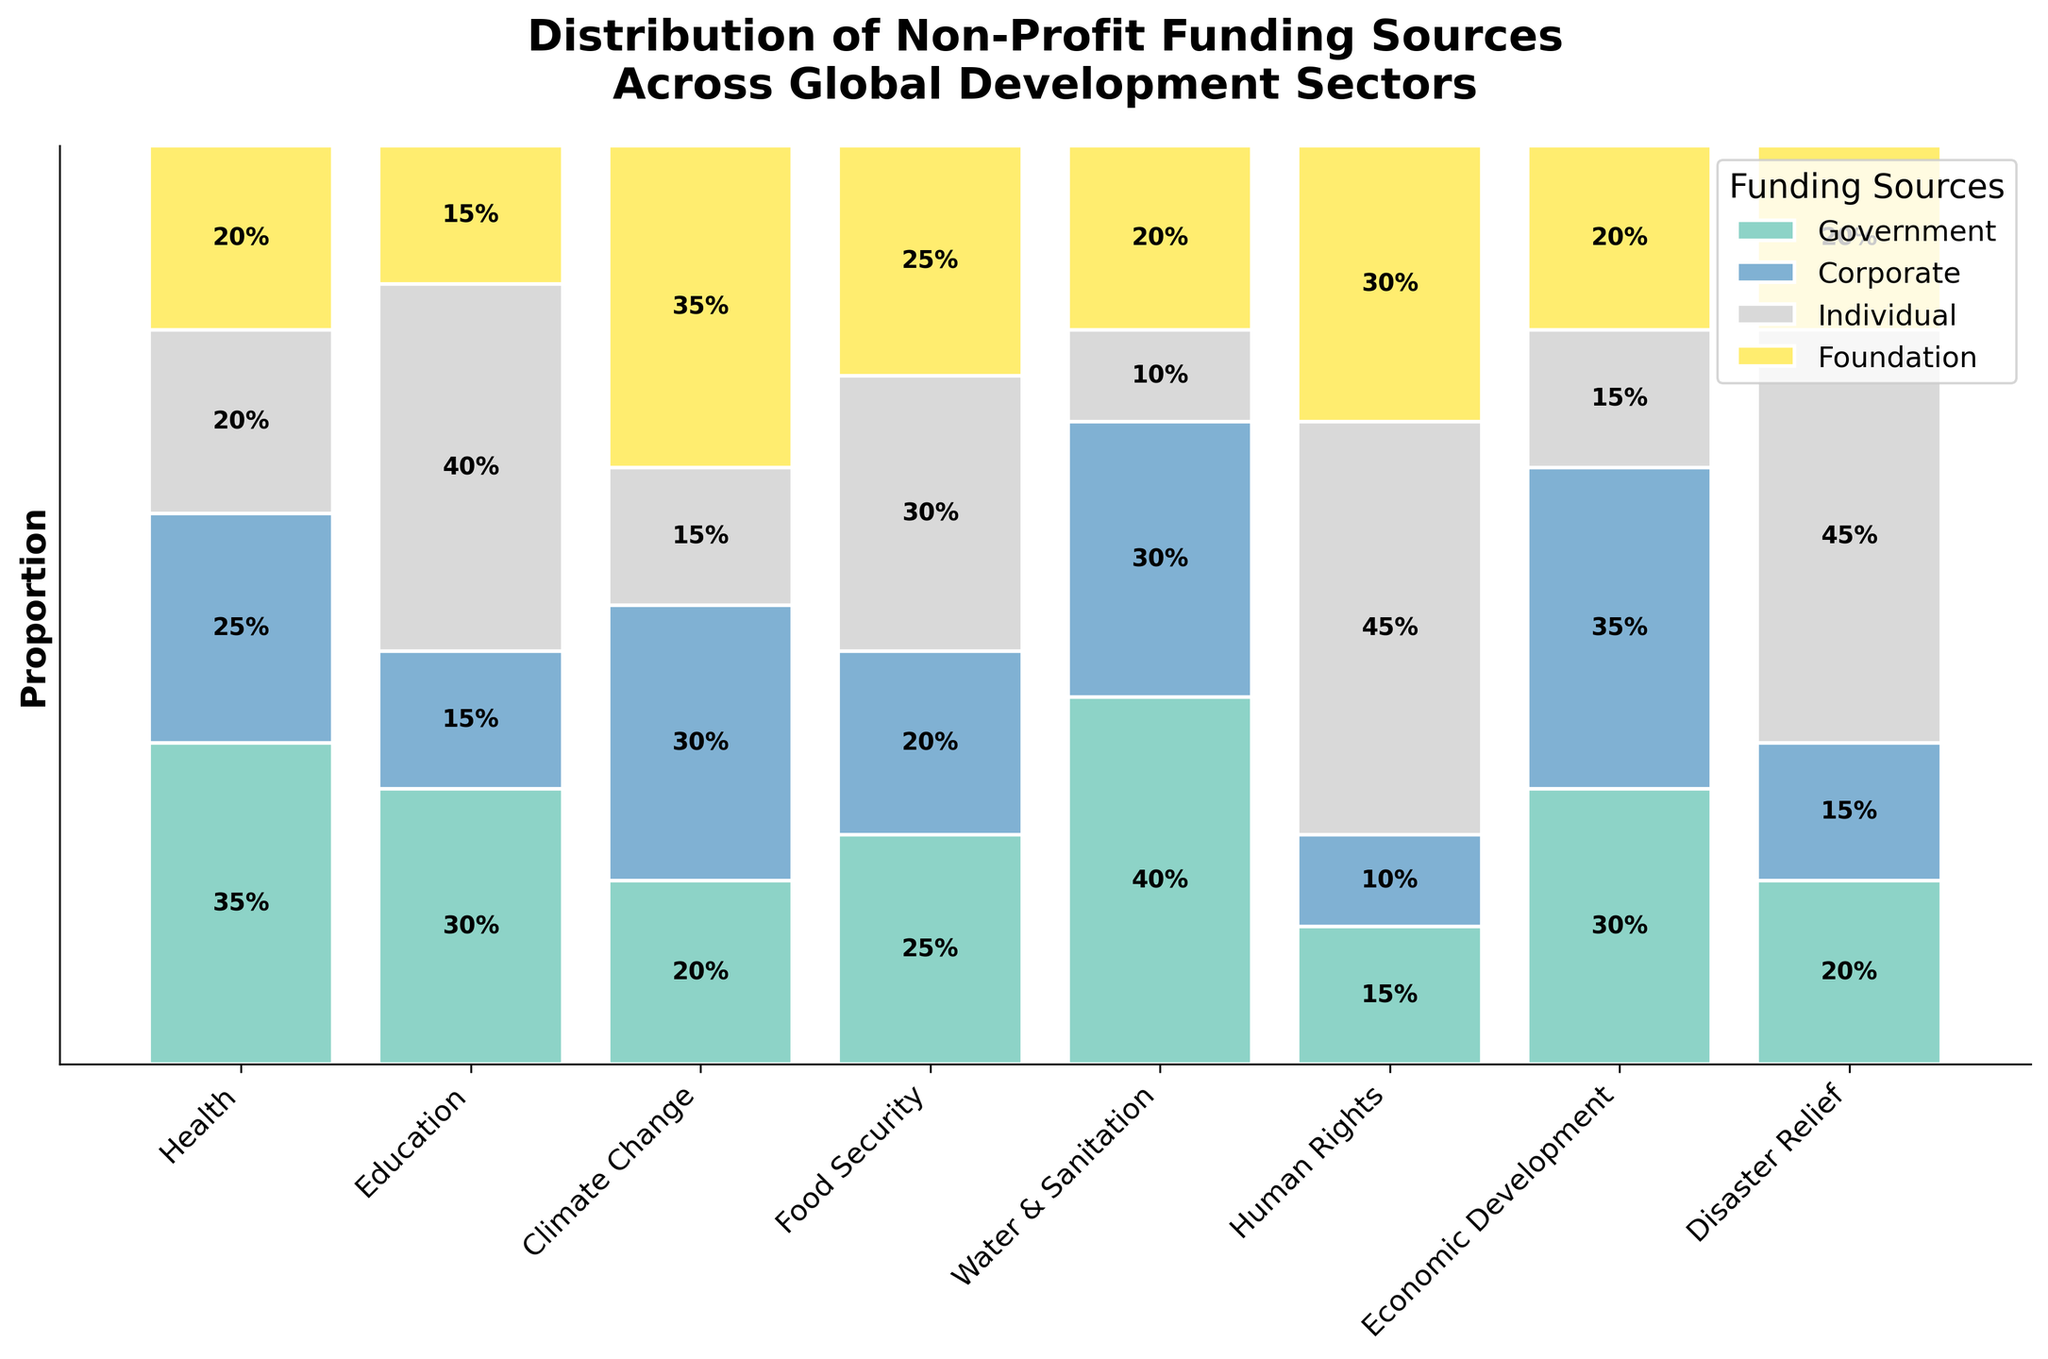What's the title of the plot? The title of the plot is located at the top of the figure, where it usually describes the content of the plot. In this case, the title is "Distribution of Non-Profit Funding Sources Across Global Development Sectors."
Answer: Distribution of Non-Profit Funding Sources Across Global Development Sectors Which sector receives the highest proportion of government funding? By observing the plot, you can determine that the "Water & Sanitation" sector has the highest proportion of government funding, which is visually evident from the height of the corresponding segment.
Answer: Water & Sanitation How many sectors receive more than 30% of their funding from individual sources? By analyzing the plot, you can identify that the sectors "Human Rights" and "Disaster Relief" have more than 30% of their funding from individual sources. This is verified through their respective heights.
Answer: 2 Which funding source is the least common for the Health sector? For the Health sector, the smallest segment on the plot corresponds to the "Individual" funding source, as it has the smallest proportional height.
Answer: Individual Compare the corporate funding proportions between Climate Change and Economic Development sectors. Which one has a higher proportion? The corporate funding proportion for the Climate Change sector can be compared visually with that of the Economic Development sector. The result shows that Economic Development has a higher proportion of corporate funding.
Answer: Economic Development Which sector has the most balanced distribution of funding sources? The Food Security sector appears to have the most balanced distribution as the segments representing each funding source have relatively similar heights.
Answer: Food Security What proportion of the Disaster Relief sector is funded by foundations? By looking at the respective segment of the Disaster Relief sector, it's clear that foundations contribute to 20% of its funding.
Answer: 20% How much more corporate funding does the Climate Change sector receive compared to the Human Rights sector? The Climate Change sector receives 30% corporate funding whereas the Human Rights sector receives only 10%. The difference is calculated as 30% - 10% = 20%.
Answer: 20% If you consider only "Government" funding, which two sectors have the closest proportions? The Health sector (35%) and Education sector (30%) have the closest government funding proportions, with only a 5% difference between them.
Answer: Health and Education 